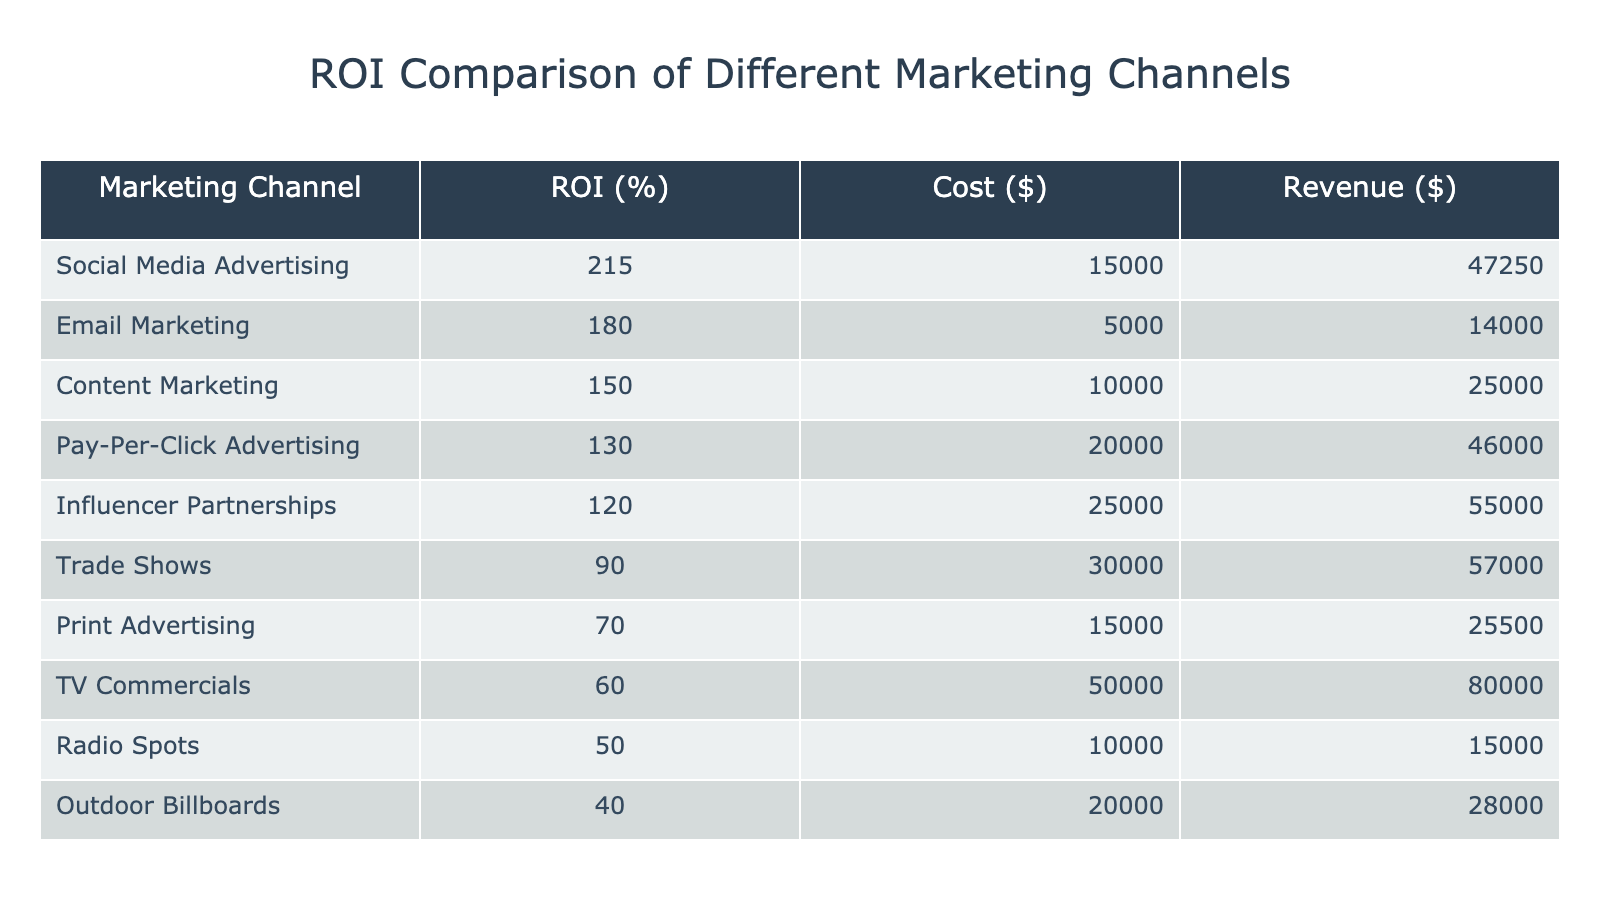What is the ROI for Social Media Advertising? According to the table, the ROI for Social Media Advertising is listed directly next to it, which shows 215%.
Answer: 215% Which marketing channel had the lowest ROI? By examining the left column for marketing channels, the lowest ROI is for Outdoor Billboards, which has an ROI of 40%.
Answer: Outdoor Billboards What is the total revenue generated from Email Marketing and Print Advertising combined? The revenue for Email Marketing is $14,000 and for Print Advertising it is $25,500. Adding these together: 14,000 + 25,500 = 39,500.
Answer: 39,500 Is the ROI for Influencer Partnerships greater than the ROI for Trade Shows? The ROI for Influencer Partnerships is 120% and for Trade Shows is 90%. Since 120% is more than 90%, the statement is true.
Answer: Yes What is the average ROI of all marketing channels listed? First, I will sum all the ROIs: 215 + 180 + 150 + 130 + 120 + 90 + 70 + 60 + 50 + 40 = 1,095. There are 10 channels, so I will divide the total ROI by the number of channels: 1,095 / 10 = 109.5.
Answer: 109.5 